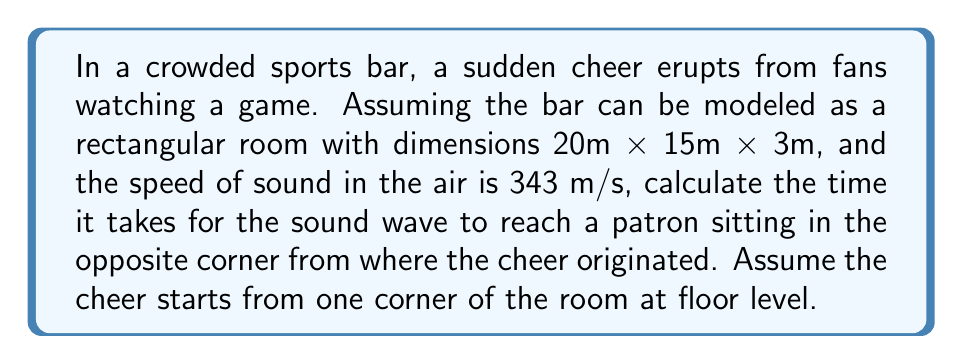Can you solve this math problem? Let's approach this step-by-step:

1) First, we need to determine the distance the sound wave travels. In a rectangular room, the sound will travel diagonally from one corner to the opposite corner.

2) We can calculate this diagonal distance using the three-dimensional Pythagorean theorem:

   $$d = \sqrt{l^2 + w^2 + h^2}$$

   Where $d$ is the diagonal distance, $l$ is length, $w$ is width, and $h$ is height.

3) Substituting our values:

   $$d = \sqrt{20^2 + 15^2 + 3^2}$$
   $$d = \sqrt{400 + 225 + 9}$$
   $$d = \sqrt{634}$$
   $$d \approx 25.18 \text{ m}$$

4) Now that we have the distance, we can use the wave equation to find the time:

   $$v = \frac{d}{t}$$

   Where $v$ is the velocity (speed of sound), $d$ is distance, and $t$ is time.

5) Rearranging to solve for $t$:

   $$t = \frac{d}{v}$$

6) Substituting our values:

   $$t = \frac{25.18 \text{ m}}{343 \text{ m/s}}$$
   $$t \approx 0.0734 \text{ s}$$

Therefore, it takes approximately 0.0734 seconds for the sound to reach the opposite corner.
Answer: 0.0734 s 